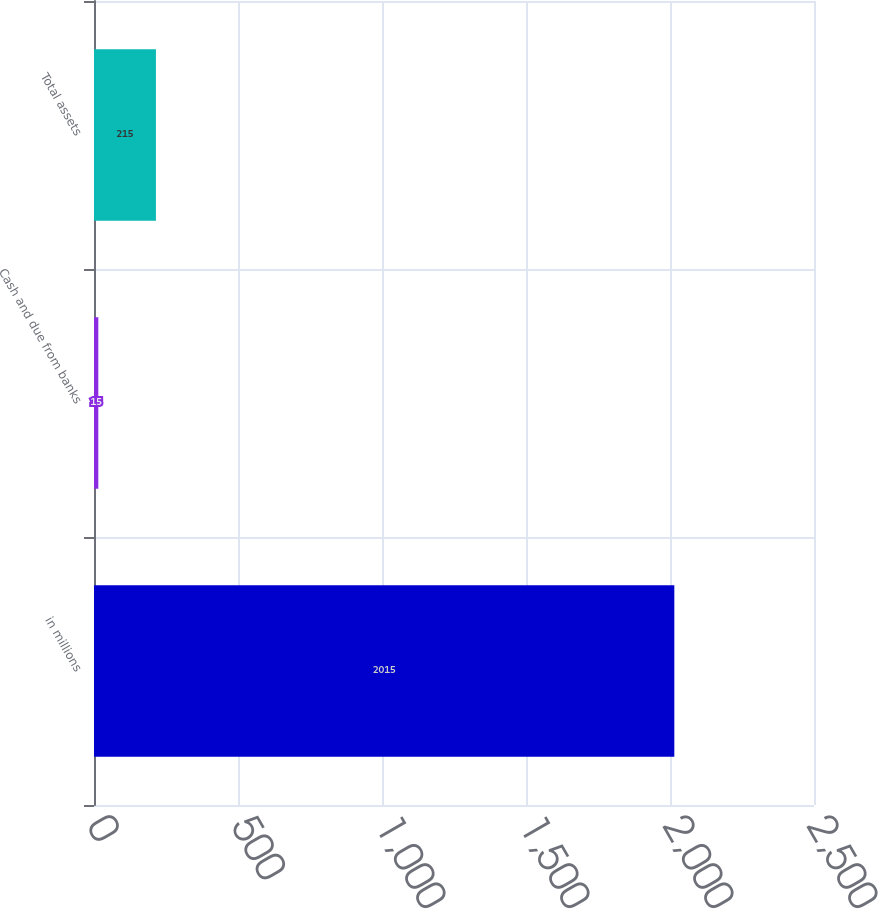Convert chart to OTSL. <chart><loc_0><loc_0><loc_500><loc_500><bar_chart><fcel>in millions<fcel>Cash and due from banks<fcel>Total assets<nl><fcel>2015<fcel>15<fcel>215<nl></chart> 